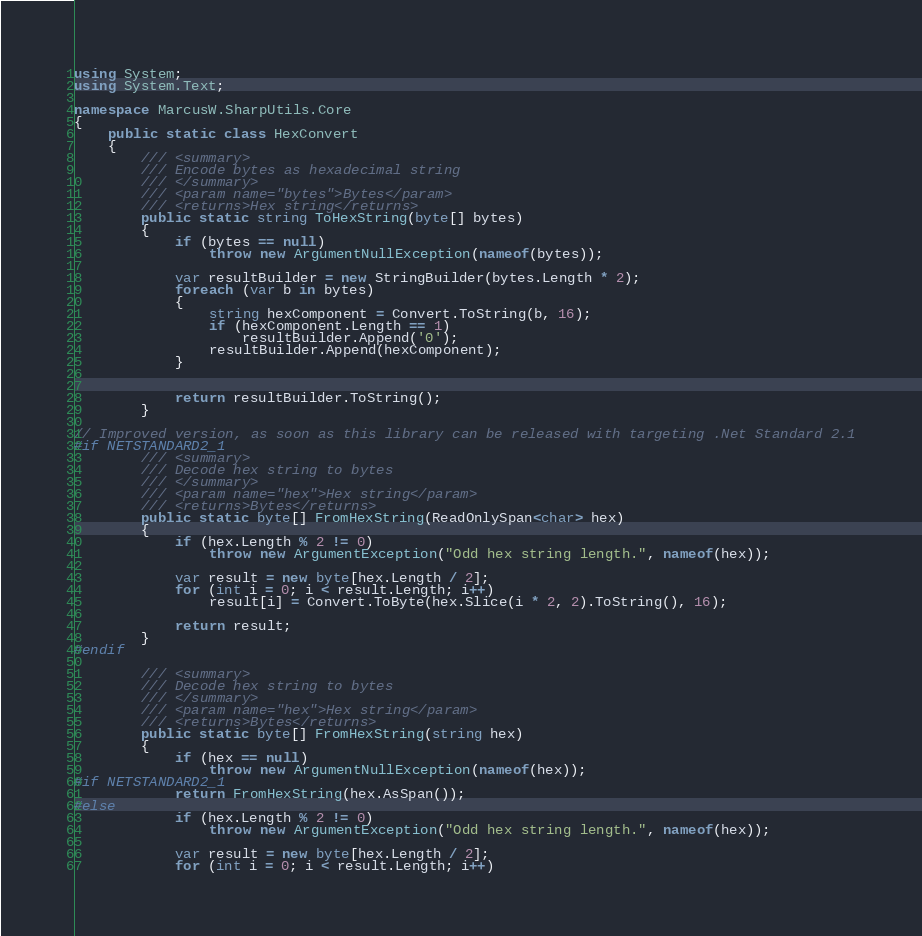Convert code to text. <code><loc_0><loc_0><loc_500><loc_500><_C#_>using System;
using System.Text;

namespace MarcusW.SharpUtils.Core
{
    public static class HexConvert
    {
        /// <summary>
        /// Encode bytes as hexadecimal string
        /// </summary>
        /// <param name="bytes">Bytes</param>
        /// <returns>Hex string</returns>
        public static string ToHexString(byte[] bytes)
        {
            if (bytes == null)
                throw new ArgumentNullException(nameof(bytes));

            var resultBuilder = new StringBuilder(bytes.Length * 2);
            foreach (var b in bytes)
            {
                string hexComponent = Convert.ToString(b, 16);
                if (hexComponent.Length == 1)
                    resultBuilder.Append('0');
                resultBuilder.Append(hexComponent);
            }


            return resultBuilder.ToString();
        }

// Improved version, as soon as this library can be released with targeting .Net Standard 2.1
#if NETSTANDARD2_1
        /// <summary>
        /// Decode hex string to bytes
        /// </summary>
        /// <param name="hex">Hex string</param>
        /// <returns>Bytes</returns>
        public static byte[] FromHexString(ReadOnlySpan<char> hex)
        {
            if (hex.Length % 2 != 0)
                throw new ArgumentException("Odd hex string length.", nameof(hex));

            var result = new byte[hex.Length / 2];
            for (int i = 0; i < result.Length; i++)
                result[i] = Convert.ToByte(hex.Slice(i * 2, 2).ToString(), 16);

            return result;
        }
#endif

        /// <summary>
        /// Decode hex string to bytes
        /// </summary>
        /// <param name="hex">Hex string</param>
        /// <returns>Bytes</returns>
        public static byte[] FromHexString(string hex)
        {
            if (hex == null)
                throw new ArgumentNullException(nameof(hex));
#if NETSTANDARD2_1
            return FromHexString(hex.AsSpan());
#else
            if (hex.Length % 2 != 0)
                throw new ArgumentException("Odd hex string length.", nameof(hex));

            var result = new byte[hex.Length / 2];
            for (int i = 0; i < result.Length; i++)</code> 